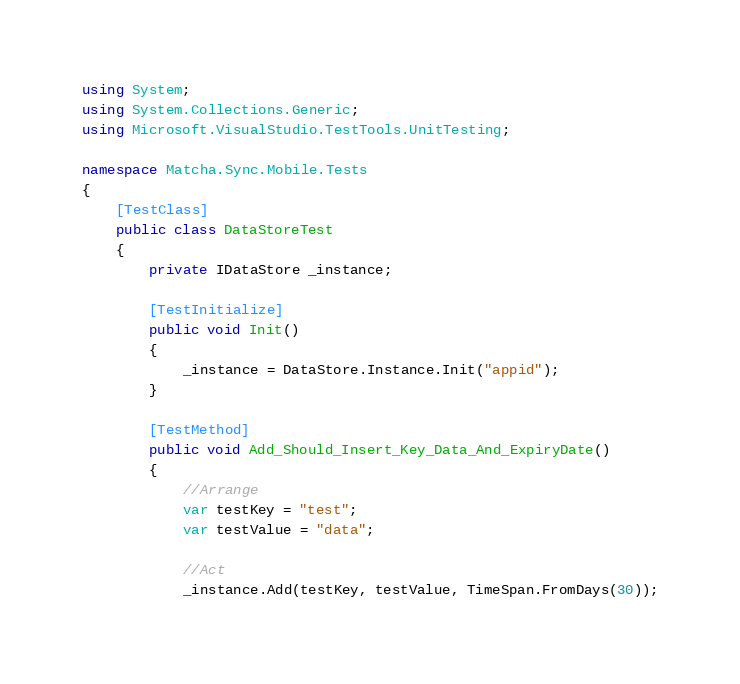<code> <loc_0><loc_0><loc_500><loc_500><_C#_>using System;
using System.Collections.Generic;
using Microsoft.VisualStudio.TestTools.UnitTesting;

namespace Matcha.Sync.Mobile.Tests
{
    [TestClass]
    public class DataStoreTest
    {
        private IDataStore _instance;

        [TestInitialize]
        public void Init()
        {
            _instance = DataStore.Instance.Init("appid");
        }

        [TestMethod]
        public void Add_Should_Insert_Key_Data_And_ExpiryDate()
        {
            //Arrange
            var testKey = "test";
            var testValue = "data";

            //Act
            _instance.Add(testKey, testValue, TimeSpan.FromDays(30));
</code> 